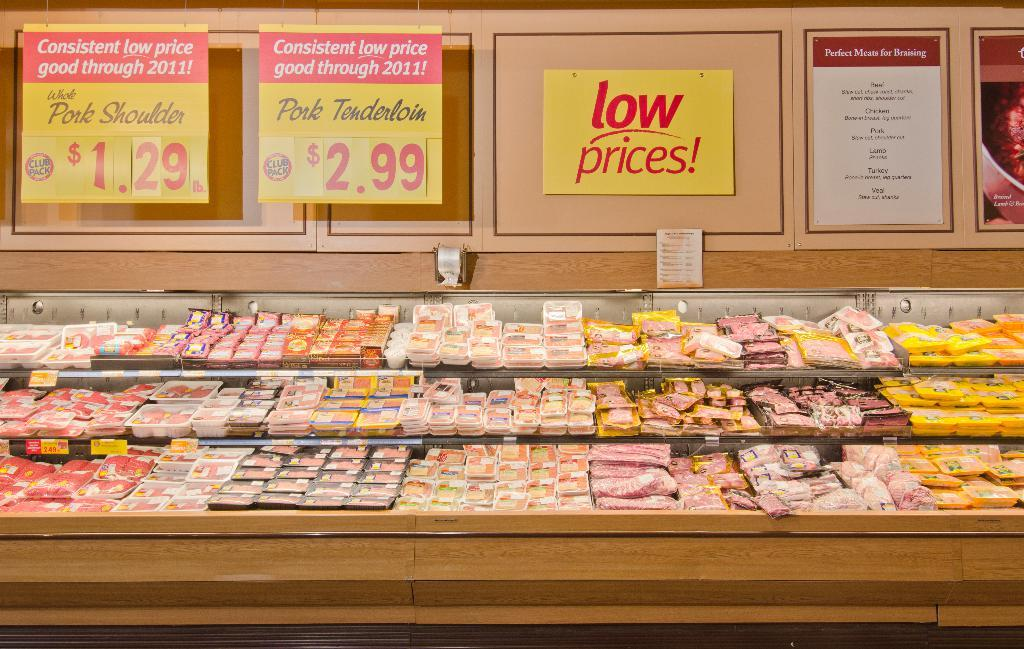Provide a one-sentence caption for the provided image. In this section of the grocery store one can purchase Pork Tenderloin at $2.99. 